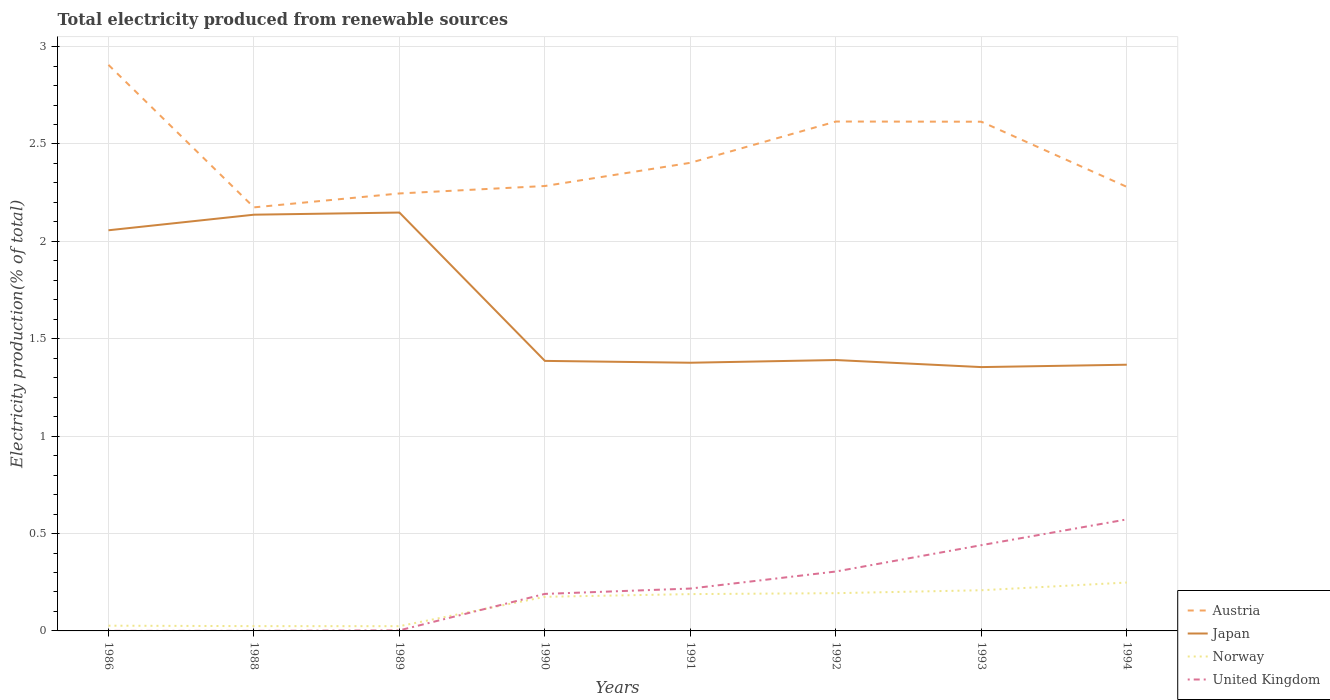Does the line corresponding to Norway intersect with the line corresponding to Japan?
Keep it short and to the point. No. Across all years, what is the maximum total electricity produced in Austria?
Ensure brevity in your answer.  2.17. What is the total total electricity produced in United Kingdom in the graph?
Offer a terse response. -0.22. What is the difference between the highest and the second highest total electricity produced in United Kingdom?
Make the answer very short. 0.57. What is the difference between the highest and the lowest total electricity produced in Austria?
Provide a short and direct response. 3. How many lines are there?
Offer a very short reply. 4. How many years are there in the graph?
Your answer should be compact. 8. What is the difference between two consecutive major ticks on the Y-axis?
Your answer should be very brief. 0.5. Does the graph contain any zero values?
Your answer should be very brief. No. Does the graph contain grids?
Your answer should be very brief. Yes. How are the legend labels stacked?
Your answer should be very brief. Vertical. What is the title of the graph?
Keep it short and to the point. Total electricity produced from renewable sources. What is the label or title of the Y-axis?
Provide a succinct answer. Electricity production(% of total). What is the Electricity production(% of total) of Austria in 1986?
Provide a short and direct response. 2.91. What is the Electricity production(% of total) in Japan in 1986?
Make the answer very short. 2.06. What is the Electricity production(% of total) in Norway in 1986?
Provide a short and direct response. 0.03. What is the Electricity production(% of total) of United Kingdom in 1986?
Ensure brevity in your answer.  0. What is the Electricity production(% of total) in Austria in 1988?
Keep it short and to the point. 2.17. What is the Electricity production(% of total) of Japan in 1988?
Give a very brief answer. 2.14. What is the Electricity production(% of total) of Norway in 1988?
Ensure brevity in your answer.  0.02. What is the Electricity production(% of total) of United Kingdom in 1988?
Offer a terse response. 0. What is the Electricity production(% of total) of Austria in 1989?
Your answer should be very brief. 2.25. What is the Electricity production(% of total) of Japan in 1989?
Your answer should be very brief. 2.15. What is the Electricity production(% of total) of Norway in 1989?
Provide a short and direct response. 0.02. What is the Electricity production(% of total) in United Kingdom in 1989?
Offer a very short reply. 0. What is the Electricity production(% of total) in Austria in 1990?
Your response must be concise. 2.28. What is the Electricity production(% of total) of Japan in 1990?
Offer a terse response. 1.39. What is the Electricity production(% of total) of Norway in 1990?
Your response must be concise. 0.18. What is the Electricity production(% of total) in United Kingdom in 1990?
Your answer should be compact. 0.19. What is the Electricity production(% of total) of Austria in 1991?
Your answer should be very brief. 2.4. What is the Electricity production(% of total) of Japan in 1991?
Your response must be concise. 1.38. What is the Electricity production(% of total) of Norway in 1991?
Your response must be concise. 0.19. What is the Electricity production(% of total) in United Kingdom in 1991?
Offer a terse response. 0.22. What is the Electricity production(% of total) in Austria in 1992?
Provide a short and direct response. 2.62. What is the Electricity production(% of total) in Japan in 1992?
Provide a short and direct response. 1.39. What is the Electricity production(% of total) of Norway in 1992?
Your response must be concise. 0.19. What is the Electricity production(% of total) in United Kingdom in 1992?
Provide a short and direct response. 0.3. What is the Electricity production(% of total) in Austria in 1993?
Offer a terse response. 2.61. What is the Electricity production(% of total) in Japan in 1993?
Ensure brevity in your answer.  1.35. What is the Electricity production(% of total) of Norway in 1993?
Provide a succinct answer. 0.21. What is the Electricity production(% of total) of United Kingdom in 1993?
Offer a very short reply. 0.44. What is the Electricity production(% of total) in Austria in 1994?
Offer a terse response. 2.28. What is the Electricity production(% of total) in Japan in 1994?
Make the answer very short. 1.37. What is the Electricity production(% of total) in Norway in 1994?
Ensure brevity in your answer.  0.25. What is the Electricity production(% of total) of United Kingdom in 1994?
Make the answer very short. 0.57. Across all years, what is the maximum Electricity production(% of total) of Austria?
Provide a succinct answer. 2.91. Across all years, what is the maximum Electricity production(% of total) of Japan?
Provide a short and direct response. 2.15. Across all years, what is the maximum Electricity production(% of total) of Norway?
Offer a very short reply. 0.25. Across all years, what is the maximum Electricity production(% of total) in United Kingdom?
Offer a terse response. 0.57. Across all years, what is the minimum Electricity production(% of total) in Austria?
Provide a short and direct response. 2.17. Across all years, what is the minimum Electricity production(% of total) of Japan?
Your answer should be very brief. 1.35. Across all years, what is the minimum Electricity production(% of total) of Norway?
Your answer should be compact. 0.02. Across all years, what is the minimum Electricity production(% of total) of United Kingdom?
Offer a terse response. 0. What is the total Electricity production(% of total) in Austria in the graph?
Keep it short and to the point. 19.52. What is the total Electricity production(% of total) of Japan in the graph?
Ensure brevity in your answer.  13.22. What is the total Electricity production(% of total) of Norway in the graph?
Keep it short and to the point. 1.09. What is the total Electricity production(% of total) in United Kingdom in the graph?
Give a very brief answer. 1.73. What is the difference between the Electricity production(% of total) of Austria in 1986 and that in 1988?
Ensure brevity in your answer.  0.73. What is the difference between the Electricity production(% of total) in Japan in 1986 and that in 1988?
Your response must be concise. -0.08. What is the difference between the Electricity production(% of total) in Norway in 1986 and that in 1988?
Your answer should be very brief. 0. What is the difference between the Electricity production(% of total) in United Kingdom in 1986 and that in 1988?
Provide a succinct answer. 0. What is the difference between the Electricity production(% of total) of Austria in 1986 and that in 1989?
Give a very brief answer. 0.66. What is the difference between the Electricity production(% of total) in Japan in 1986 and that in 1989?
Your response must be concise. -0.09. What is the difference between the Electricity production(% of total) of Norway in 1986 and that in 1989?
Give a very brief answer. 0. What is the difference between the Electricity production(% of total) in United Kingdom in 1986 and that in 1989?
Your answer should be compact. -0. What is the difference between the Electricity production(% of total) in Austria in 1986 and that in 1990?
Provide a succinct answer. 0.62. What is the difference between the Electricity production(% of total) of Japan in 1986 and that in 1990?
Give a very brief answer. 0.67. What is the difference between the Electricity production(% of total) in Norway in 1986 and that in 1990?
Provide a short and direct response. -0.15. What is the difference between the Electricity production(% of total) in United Kingdom in 1986 and that in 1990?
Offer a very short reply. -0.19. What is the difference between the Electricity production(% of total) in Austria in 1986 and that in 1991?
Your answer should be compact. 0.5. What is the difference between the Electricity production(% of total) in Japan in 1986 and that in 1991?
Ensure brevity in your answer.  0.68. What is the difference between the Electricity production(% of total) in Norway in 1986 and that in 1991?
Provide a succinct answer. -0.16. What is the difference between the Electricity production(% of total) of United Kingdom in 1986 and that in 1991?
Provide a succinct answer. -0.22. What is the difference between the Electricity production(% of total) in Austria in 1986 and that in 1992?
Your answer should be very brief. 0.29. What is the difference between the Electricity production(% of total) of Japan in 1986 and that in 1992?
Make the answer very short. 0.67. What is the difference between the Electricity production(% of total) of Norway in 1986 and that in 1992?
Offer a terse response. -0.17. What is the difference between the Electricity production(% of total) of United Kingdom in 1986 and that in 1992?
Provide a succinct answer. -0.3. What is the difference between the Electricity production(% of total) of Austria in 1986 and that in 1993?
Your response must be concise. 0.29. What is the difference between the Electricity production(% of total) in Japan in 1986 and that in 1993?
Your answer should be compact. 0.7. What is the difference between the Electricity production(% of total) of Norway in 1986 and that in 1993?
Offer a very short reply. -0.18. What is the difference between the Electricity production(% of total) of United Kingdom in 1986 and that in 1993?
Your answer should be compact. -0.44. What is the difference between the Electricity production(% of total) in Austria in 1986 and that in 1994?
Your response must be concise. 0.63. What is the difference between the Electricity production(% of total) in Japan in 1986 and that in 1994?
Offer a terse response. 0.69. What is the difference between the Electricity production(% of total) of Norway in 1986 and that in 1994?
Give a very brief answer. -0.22. What is the difference between the Electricity production(% of total) in United Kingdom in 1986 and that in 1994?
Your response must be concise. -0.57. What is the difference between the Electricity production(% of total) in Austria in 1988 and that in 1989?
Provide a succinct answer. -0.07. What is the difference between the Electricity production(% of total) of Japan in 1988 and that in 1989?
Your answer should be compact. -0.01. What is the difference between the Electricity production(% of total) of Norway in 1988 and that in 1989?
Provide a short and direct response. 0. What is the difference between the Electricity production(% of total) of United Kingdom in 1988 and that in 1989?
Ensure brevity in your answer.  -0. What is the difference between the Electricity production(% of total) in Austria in 1988 and that in 1990?
Your response must be concise. -0.11. What is the difference between the Electricity production(% of total) in Japan in 1988 and that in 1990?
Provide a succinct answer. 0.75. What is the difference between the Electricity production(% of total) in Norway in 1988 and that in 1990?
Give a very brief answer. -0.15. What is the difference between the Electricity production(% of total) in United Kingdom in 1988 and that in 1990?
Make the answer very short. -0.19. What is the difference between the Electricity production(% of total) of Austria in 1988 and that in 1991?
Your answer should be very brief. -0.23. What is the difference between the Electricity production(% of total) in Japan in 1988 and that in 1991?
Your answer should be very brief. 0.76. What is the difference between the Electricity production(% of total) in Norway in 1988 and that in 1991?
Your answer should be very brief. -0.16. What is the difference between the Electricity production(% of total) of United Kingdom in 1988 and that in 1991?
Keep it short and to the point. -0.22. What is the difference between the Electricity production(% of total) of Austria in 1988 and that in 1992?
Provide a short and direct response. -0.44. What is the difference between the Electricity production(% of total) of Japan in 1988 and that in 1992?
Your answer should be very brief. 0.75. What is the difference between the Electricity production(% of total) of Norway in 1988 and that in 1992?
Your answer should be compact. -0.17. What is the difference between the Electricity production(% of total) in United Kingdom in 1988 and that in 1992?
Keep it short and to the point. -0.3. What is the difference between the Electricity production(% of total) of Austria in 1988 and that in 1993?
Keep it short and to the point. -0.44. What is the difference between the Electricity production(% of total) in Japan in 1988 and that in 1993?
Make the answer very short. 0.78. What is the difference between the Electricity production(% of total) in Norway in 1988 and that in 1993?
Give a very brief answer. -0.18. What is the difference between the Electricity production(% of total) of United Kingdom in 1988 and that in 1993?
Offer a very short reply. -0.44. What is the difference between the Electricity production(% of total) in Austria in 1988 and that in 1994?
Ensure brevity in your answer.  -0.11. What is the difference between the Electricity production(% of total) in Japan in 1988 and that in 1994?
Provide a succinct answer. 0.77. What is the difference between the Electricity production(% of total) of Norway in 1988 and that in 1994?
Provide a short and direct response. -0.22. What is the difference between the Electricity production(% of total) in United Kingdom in 1988 and that in 1994?
Your response must be concise. -0.57. What is the difference between the Electricity production(% of total) of Austria in 1989 and that in 1990?
Provide a succinct answer. -0.04. What is the difference between the Electricity production(% of total) of Japan in 1989 and that in 1990?
Give a very brief answer. 0.76. What is the difference between the Electricity production(% of total) of Norway in 1989 and that in 1990?
Offer a very short reply. -0.15. What is the difference between the Electricity production(% of total) in United Kingdom in 1989 and that in 1990?
Make the answer very short. -0.19. What is the difference between the Electricity production(% of total) in Austria in 1989 and that in 1991?
Your response must be concise. -0.16. What is the difference between the Electricity production(% of total) in Japan in 1989 and that in 1991?
Offer a terse response. 0.77. What is the difference between the Electricity production(% of total) in Norway in 1989 and that in 1991?
Ensure brevity in your answer.  -0.16. What is the difference between the Electricity production(% of total) of United Kingdom in 1989 and that in 1991?
Provide a short and direct response. -0.21. What is the difference between the Electricity production(% of total) in Austria in 1989 and that in 1992?
Provide a short and direct response. -0.37. What is the difference between the Electricity production(% of total) in Japan in 1989 and that in 1992?
Keep it short and to the point. 0.76. What is the difference between the Electricity production(% of total) in Norway in 1989 and that in 1992?
Keep it short and to the point. -0.17. What is the difference between the Electricity production(% of total) in United Kingdom in 1989 and that in 1992?
Your answer should be compact. -0.3. What is the difference between the Electricity production(% of total) of Austria in 1989 and that in 1993?
Provide a short and direct response. -0.37. What is the difference between the Electricity production(% of total) in Japan in 1989 and that in 1993?
Provide a short and direct response. 0.79. What is the difference between the Electricity production(% of total) of Norway in 1989 and that in 1993?
Ensure brevity in your answer.  -0.18. What is the difference between the Electricity production(% of total) in United Kingdom in 1989 and that in 1993?
Your response must be concise. -0.44. What is the difference between the Electricity production(% of total) in Austria in 1989 and that in 1994?
Your answer should be compact. -0.03. What is the difference between the Electricity production(% of total) in Japan in 1989 and that in 1994?
Keep it short and to the point. 0.78. What is the difference between the Electricity production(% of total) of Norway in 1989 and that in 1994?
Keep it short and to the point. -0.22. What is the difference between the Electricity production(% of total) in United Kingdom in 1989 and that in 1994?
Keep it short and to the point. -0.57. What is the difference between the Electricity production(% of total) of Austria in 1990 and that in 1991?
Provide a succinct answer. -0.12. What is the difference between the Electricity production(% of total) in Japan in 1990 and that in 1991?
Provide a short and direct response. 0.01. What is the difference between the Electricity production(% of total) in Norway in 1990 and that in 1991?
Provide a short and direct response. -0.01. What is the difference between the Electricity production(% of total) in United Kingdom in 1990 and that in 1991?
Give a very brief answer. -0.03. What is the difference between the Electricity production(% of total) of Austria in 1990 and that in 1992?
Offer a terse response. -0.33. What is the difference between the Electricity production(% of total) of Japan in 1990 and that in 1992?
Your response must be concise. -0. What is the difference between the Electricity production(% of total) in Norway in 1990 and that in 1992?
Offer a very short reply. -0.02. What is the difference between the Electricity production(% of total) of United Kingdom in 1990 and that in 1992?
Make the answer very short. -0.11. What is the difference between the Electricity production(% of total) of Austria in 1990 and that in 1993?
Provide a succinct answer. -0.33. What is the difference between the Electricity production(% of total) of Japan in 1990 and that in 1993?
Your answer should be compact. 0.03. What is the difference between the Electricity production(% of total) in Norway in 1990 and that in 1993?
Your answer should be compact. -0.03. What is the difference between the Electricity production(% of total) of United Kingdom in 1990 and that in 1993?
Give a very brief answer. -0.25. What is the difference between the Electricity production(% of total) in Austria in 1990 and that in 1994?
Provide a succinct answer. 0. What is the difference between the Electricity production(% of total) in Japan in 1990 and that in 1994?
Ensure brevity in your answer.  0.02. What is the difference between the Electricity production(% of total) in Norway in 1990 and that in 1994?
Offer a terse response. -0.07. What is the difference between the Electricity production(% of total) of United Kingdom in 1990 and that in 1994?
Provide a succinct answer. -0.38. What is the difference between the Electricity production(% of total) in Austria in 1991 and that in 1992?
Keep it short and to the point. -0.21. What is the difference between the Electricity production(% of total) of Japan in 1991 and that in 1992?
Make the answer very short. -0.01. What is the difference between the Electricity production(% of total) of Norway in 1991 and that in 1992?
Ensure brevity in your answer.  -0. What is the difference between the Electricity production(% of total) of United Kingdom in 1991 and that in 1992?
Offer a terse response. -0.09. What is the difference between the Electricity production(% of total) of Austria in 1991 and that in 1993?
Provide a short and direct response. -0.21. What is the difference between the Electricity production(% of total) in Japan in 1991 and that in 1993?
Your answer should be very brief. 0.02. What is the difference between the Electricity production(% of total) in Norway in 1991 and that in 1993?
Your answer should be very brief. -0.02. What is the difference between the Electricity production(% of total) in United Kingdom in 1991 and that in 1993?
Your response must be concise. -0.22. What is the difference between the Electricity production(% of total) in Austria in 1991 and that in 1994?
Your answer should be compact. 0.12. What is the difference between the Electricity production(% of total) in Japan in 1991 and that in 1994?
Keep it short and to the point. 0.01. What is the difference between the Electricity production(% of total) in Norway in 1991 and that in 1994?
Your answer should be compact. -0.06. What is the difference between the Electricity production(% of total) of United Kingdom in 1991 and that in 1994?
Give a very brief answer. -0.36. What is the difference between the Electricity production(% of total) in Austria in 1992 and that in 1993?
Your response must be concise. 0. What is the difference between the Electricity production(% of total) of Japan in 1992 and that in 1993?
Ensure brevity in your answer.  0.04. What is the difference between the Electricity production(% of total) of Norway in 1992 and that in 1993?
Your response must be concise. -0.01. What is the difference between the Electricity production(% of total) of United Kingdom in 1992 and that in 1993?
Your response must be concise. -0.14. What is the difference between the Electricity production(% of total) of Austria in 1992 and that in 1994?
Your answer should be compact. 0.34. What is the difference between the Electricity production(% of total) of Japan in 1992 and that in 1994?
Your answer should be very brief. 0.02. What is the difference between the Electricity production(% of total) in Norway in 1992 and that in 1994?
Your answer should be very brief. -0.05. What is the difference between the Electricity production(% of total) in United Kingdom in 1992 and that in 1994?
Give a very brief answer. -0.27. What is the difference between the Electricity production(% of total) of Austria in 1993 and that in 1994?
Offer a terse response. 0.33. What is the difference between the Electricity production(% of total) of Japan in 1993 and that in 1994?
Offer a very short reply. -0.01. What is the difference between the Electricity production(% of total) of Norway in 1993 and that in 1994?
Offer a terse response. -0.04. What is the difference between the Electricity production(% of total) of United Kingdom in 1993 and that in 1994?
Your response must be concise. -0.13. What is the difference between the Electricity production(% of total) of Austria in 1986 and the Electricity production(% of total) of Japan in 1988?
Your response must be concise. 0.77. What is the difference between the Electricity production(% of total) of Austria in 1986 and the Electricity production(% of total) of Norway in 1988?
Give a very brief answer. 2.88. What is the difference between the Electricity production(% of total) in Austria in 1986 and the Electricity production(% of total) in United Kingdom in 1988?
Make the answer very short. 2.91. What is the difference between the Electricity production(% of total) of Japan in 1986 and the Electricity production(% of total) of Norway in 1988?
Offer a very short reply. 2.03. What is the difference between the Electricity production(% of total) of Japan in 1986 and the Electricity production(% of total) of United Kingdom in 1988?
Provide a succinct answer. 2.06. What is the difference between the Electricity production(% of total) in Norway in 1986 and the Electricity production(% of total) in United Kingdom in 1988?
Your response must be concise. 0.03. What is the difference between the Electricity production(% of total) in Austria in 1986 and the Electricity production(% of total) in Japan in 1989?
Give a very brief answer. 0.76. What is the difference between the Electricity production(% of total) in Austria in 1986 and the Electricity production(% of total) in Norway in 1989?
Ensure brevity in your answer.  2.88. What is the difference between the Electricity production(% of total) of Austria in 1986 and the Electricity production(% of total) of United Kingdom in 1989?
Keep it short and to the point. 2.9. What is the difference between the Electricity production(% of total) in Japan in 1986 and the Electricity production(% of total) in Norway in 1989?
Give a very brief answer. 2.03. What is the difference between the Electricity production(% of total) in Japan in 1986 and the Electricity production(% of total) in United Kingdom in 1989?
Your response must be concise. 2.05. What is the difference between the Electricity production(% of total) in Norway in 1986 and the Electricity production(% of total) in United Kingdom in 1989?
Your answer should be very brief. 0.02. What is the difference between the Electricity production(% of total) of Austria in 1986 and the Electricity production(% of total) of Japan in 1990?
Offer a very short reply. 1.52. What is the difference between the Electricity production(% of total) in Austria in 1986 and the Electricity production(% of total) in Norway in 1990?
Your answer should be very brief. 2.73. What is the difference between the Electricity production(% of total) of Austria in 1986 and the Electricity production(% of total) of United Kingdom in 1990?
Offer a terse response. 2.72. What is the difference between the Electricity production(% of total) in Japan in 1986 and the Electricity production(% of total) in Norway in 1990?
Give a very brief answer. 1.88. What is the difference between the Electricity production(% of total) of Japan in 1986 and the Electricity production(% of total) of United Kingdom in 1990?
Ensure brevity in your answer.  1.87. What is the difference between the Electricity production(% of total) in Norway in 1986 and the Electricity production(% of total) in United Kingdom in 1990?
Offer a terse response. -0.16. What is the difference between the Electricity production(% of total) in Austria in 1986 and the Electricity production(% of total) in Japan in 1991?
Ensure brevity in your answer.  1.53. What is the difference between the Electricity production(% of total) of Austria in 1986 and the Electricity production(% of total) of Norway in 1991?
Provide a succinct answer. 2.72. What is the difference between the Electricity production(% of total) in Austria in 1986 and the Electricity production(% of total) in United Kingdom in 1991?
Provide a short and direct response. 2.69. What is the difference between the Electricity production(% of total) in Japan in 1986 and the Electricity production(% of total) in Norway in 1991?
Give a very brief answer. 1.87. What is the difference between the Electricity production(% of total) in Japan in 1986 and the Electricity production(% of total) in United Kingdom in 1991?
Offer a terse response. 1.84. What is the difference between the Electricity production(% of total) in Norway in 1986 and the Electricity production(% of total) in United Kingdom in 1991?
Ensure brevity in your answer.  -0.19. What is the difference between the Electricity production(% of total) in Austria in 1986 and the Electricity production(% of total) in Japan in 1992?
Provide a short and direct response. 1.52. What is the difference between the Electricity production(% of total) of Austria in 1986 and the Electricity production(% of total) of Norway in 1992?
Give a very brief answer. 2.71. What is the difference between the Electricity production(% of total) in Austria in 1986 and the Electricity production(% of total) in United Kingdom in 1992?
Offer a very short reply. 2.6. What is the difference between the Electricity production(% of total) in Japan in 1986 and the Electricity production(% of total) in Norway in 1992?
Keep it short and to the point. 1.86. What is the difference between the Electricity production(% of total) in Japan in 1986 and the Electricity production(% of total) in United Kingdom in 1992?
Keep it short and to the point. 1.75. What is the difference between the Electricity production(% of total) of Norway in 1986 and the Electricity production(% of total) of United Kingdom in 1992?
Your response must be concise. -0.28. What is the difference between the Electricity production(% of total) of Austria in 1986 and the Electricity production(% of total) of Japan in 1993?
Make the answer very short. 1.55. What is the difference between the Electricity production(% of total) in Austria in 1986 and the Electricity production(% of total) in Norway in 1993?
Keep it short and to the point. 2.7. What is the difference between the Electricity production(% of total) of Austria in 1986 and the Electricity production(% of total) of United Kingdom in 1993?
Offer a terse response. 2.47. What is the difference between the Electricity production(% of total) of Japan in 1986 and the Electricity production(% of total) of Norway in 1993?
Keep it short and to the point. 1.85. What is the difference between the Electricity production(% of total) in Japan in 1986 and the Electricity production(% of total) in United Kingdom in 1993?
Offer a very short reply. 1.62. What is the difference between the Electricity production(% of total) of Norway in 1986 and the Electricity production(% of total) of United Kingdom in 1993?
Keep it short and to the point. -0.41. What is the difference between the Electricity production(% of total) of Austria in 1986 and the Electricity production(% of total) of Japan in 1994?
Offer a terse response. 1.54. What is the difference between the Electricity production(% of total) of Austria in 1986 and the Electricity production(% of total) of Norway in 1994?
Your answer should be very brief. 2.66. What is the difference between the Electricity production(% of total) in Austria in 1986 and the Electricity production(% of total) in United Kingdom in 1994?
Your answer should be very brief. 2.33. What is the difference between the Electricity production(% of total) in Japan in 1986 and the Electricity production(% of total) in Norway in 1994?
Provide a short and direct response. 1.81. What is the difference between the Electricity production(% of total) in Japan in 1986 and the Electricity production(% of total) in United Kingdom in 1994?
Keep it short and to the point. 1.48. What is the difference between the Electricity production(% of total) in Norway in 1986 and the Electricity production(% of total) in United Kingdom in 1994?
Your answer should be compact. -0.55. What is the difference between the Electricity production(% of total) in Austria in 1988 and the Electricity production(% of total) in Japan in 1989?
Provide a short and direct response. 0.03. What is the difference between the Electricity production(% of total) in Austria in 1988 and the Electricity production(% of total) in Norway in 1989?
Keep it short and to the point. 2.15. What is the difference between the Electricity production(% of total) in Austria in 1988 and the Electricity production(% of total) in United Kingdom in 1989?
Your response must be concise. 2.17. What is the difference between the Electricity production(% of total) of Japan in 1988 and the Electricity production(% of total) of Norway in 1989?
Offer a terse response. 2.11. What is the difference between the Electricity production(% of total) in Japan in 1988 and the Electricity production(% of total) in United Kingdom in 1989?
Offer a very short reply. 2.13. What is the difference between the Electricity production(% of total) in Norway in 1988 and the Electricity production(% of total) in United Kingdom in 1989?
Provide a short and direct response. 0.02. What is the difference between the Electricity production(% of total) of Austria in 1988 and the Electricity production(% of total) of Japan in 1990?
Provide a succinct answer. 0.79. What is the difference between the Electricity production(% of total) in Austria in 1988 and the Electricity production(% of total) in Norway in 1990?
Offer a very short reply. 2. What is the difference between the Electricity production(% of total) of Austria in 1988 and the Electricity production(% of total) of United Kingdom in 1990?
Provide a succinct answer. 1.98. What is the difference between the Electricity production(% of total) in Japan in 1988 and the Electricity production(% of total) in Norway in 1990?
Provide a short and direct response. 1.96. What is the difference between the Electricity production(% of total) in Japan in 1988 and the Electricity production(% of total) in United Kingdom in 1990?
Make the answer very short. 1.95. What is the difference between the Electricity production(% of total) of Norway in 1988 and the Electricity production(% of total) of United Kingdom in 1990?
Keep it short and to the point. -0.17. What is the difference between the Electricity production(% of total) of Austria in 1988 and the Electricity production(% of total) of Japan in 1991?
Give a very brief answer. 0.8. What is the difference between the Electricity production(% of total) of Austria in 1988 and the Electricity production(% of total) of Norway in 1991?
Make the answer very short. 1.99. What is the difference between the Electricity production(% of total) in Austria in 1988 and the Electricity production(% of total) in United Kingdom in 1991?
Provide a succinct answer. 1.96. What is the difference between the Electricity production(% of total) in Japan in 1988 and the Electricity production(% of total) in Norway in 1991?
Offer a very short reply. 1.95. What is the difference between the Electricity production(% of total) in Japan in 1988 and the Electricity production(% of total) in United Kingdom in 1991?
Offer a terse response. 1.92. What is the difference between the Electricity production(% of total) in Norway in 1988 and the Electricity production(% of total) in United Kingdom in 1991?
Offer a very short reply. -0.19. What is the difference between the Electricity production(% of total) in Austria in 1988 and the Electricity production(% of total) in Japan in 1992?
Make the answer very short. 0.78. What is the difference between the Electricity production(% of total) in Austria in 1988 and the Electricity production(% of total) in Norway in 1992?
Ensure brevity in your answer.  1.98. What is the difference between the Electricity production(% of total) in Austria in 1988 and the Electricity production(% of total) in United Kingdom in 1992?
Offer a very short reply. 1.87. What is the difference between the Electricity production(% of total) in Japan in 1988 and the Electricity production(% of total) in Norway in 1992?
Give a very brief answer. 1.94. What is the difference between the Electricity production(% of total) of Japan in 1988 and the Electricity production(% of total) of United Kingdom in 1992?
Ensure brevity in your answer.  1.83. What is the difference between the Electricity production(% of total) of Norway in 1988 and the Electricity production(% of total) of United Kingdom in 1992?
Provide a short and direct response. -0.28. What is the difference between the Electricity production(% of total) in Austria in 1988 and the Electricity production(% of total) in Japan in 1993?
Provide a succinct answer. 0.82. What is the difference between the Electricity production(% of total) of Austria in 1988 and the Electricity production(% of total) of Norway in 1993?
Make the answer very short. 1.97. What is the difference between the Electricity production(% of total) of Austria in 1988 and the Electricity production(% of total) of United Kingdom in 1993?
Your response must be concise. 1.73. What is the difference between the Electricity production(% of total) of Japan in 1988 and the Electricity production(% of total) of Norway in 1993?
Your answer should be very brief. 1.93. What is the difference between the Electricity production(% of total) in Japan in 1988 and the Electricity production(% of total) in United Kingdom in 1993?
Give a very brief answer. 1.7. What is the difference between the Electricity production(% of total) in Norway in 1988 and the Electricity production(% of total) in United Kingdom in 1993?
Give a very brief answer. -0.42. What is the difference between the Electricity production(% of total) of Austria in 1988 and the Electricity production(% of total) of Japan in 1994?
Offer a very short reply. 0.81. What is the difference between the Electricity production(% of total) in Austria in 1988 and the Electricity production(% of total) in Norway in 1994?
Give a very brief answer. 1.93. What is the difference between the Electricity production(% of total) of Austria in 1988 and the Electricity production(% of total) of United Kingdom in 1994?
Your response must be concise. 1.6. What is the difference between the Electricity production(% of total) in Japan in 1988 and the Electricity production(% of total) in Norway in 1994?
Your answer should be very brief. 1.89. What is the difference between the Electricity production(% of total) in Japan in 1988 and the Electricity production(% of total) in United Kingdom in 1994?
Offer a very short reply. 1.56. What is the difference between the Electricity production(% of total) of Norway in 1988 and the Electricity production(% of total) of United Kingdom in 1994?
Make the answer very short. -0.55. What is the difference between the Electricity production(% of total) of Austria in 1989 and the Electricity production(% of total) of Japan in 1990?
Your response must be concise. 0.86. What is the difference between the Electricity production(% of total) of Austria in 1989 and the Electricity production(% of total) of Norway in 1990?
Keep it short and to the point. 2.07. What is the difference between the Electricity production(% of total) in Austria in 1989 and the Electricity production(% of total) in United Kingdom in 1990?
Offer a very short reply. 2.06. What is the difference between the Electricity production(% of total) in Japan in 1989 and the Electricity production(% of total) in Norway in 1990?
Give a very brief answer. 1.97. What is the difference between the Electricity production(% of total) of Japan in 1989 and the Electricity production(% of total) of United Kingdom in 1990?
Your response must be concise. 1.96. What is the difference between the Electricity production(% of total) in Norway in 1989 and the Electricity production(% of total) in United Kingdom in 1990?
Ensure brevity in your answer.  -0.17. What is the difference between the Electricity production(% of total) in Austria in 1989 and the Electricity production(% of total) in Japan in 1991?
Provide a short and direct response. 0.87. What is the difference between the Electricity production(% of total) of Austria in 1989 and the Electricity production(% of total) of Norway in 1991?
Make the answer very short. 2.06. What is the difference between the Electricity production(% of total) of Austria in 1989 and the Electricity production(% of total) of United Kingdom in 1991?
Provide a short and direct response. 2.03. What is the difference between the Electricity production(% of total) in Japan in 1989 and the Electricity production(% of total) in Norway in 1991?
Ensure brevity in your answer.  1.96. What is the difference between the Electricity production(% of total) in Japan in 1989 and the Electricity production(% of total) in United Kingdom in 1991?
Ensure brevity in your answer.  1.93. What is the difference between the Electricity production(% of total) in Norway in 1989 and the Electricity production(% of total) in United Kingdom in 1991?
Provide a succinct answer. -0.19. What is the difference between the Electricity production(% of total) of Austria in 1989 and the Electricity production(% of total) of Japan in 1992?
Your response must be concise. 0.86. What is the difference between the Electricity production(% of total) of Austria in 1989 and the Electricity production(% of total) of Norway in 1992?
Keep it short and to the point. 2.05. What is the difference between the Electricity production(% of total) in Austria in 1989 and the Electricity production(% of total) in United Kingdom in 1992?
Your answer should be compact. 1.94. What is the difference between the Electricity production(% of total) of Japan in 1989 and the Electricity production(% of total) of Norway in 1992?
Offer a terse response. 1.95. What is the difference between the Electricity production(% of total) in Japan in 1989 and the Electricity production(% of total) in United Kingdom in 1992?
Give a very brief answer. 1.84. What is the difference between the Electricity production(% of total) in Norway in 1989 and the Electricity production(% of total) in United Kingdom in 1992?
Keep it short and to the point. -0.28. What is the difference between the Electricity production(% of total) of Austria in 1989 and the Electricity production(% of total) of Japan in 1993?
Your answer should be very brief. 0.89. What is the difference between the Electricity production(% of total) in Austria in 1989 and the Electricity production(% of total) in Norway in 1993?
Ensure brevity in your answer.  2.04. What is the difference between the Electricity production(% of total) in Austria in 1989 and the Electricity production(% of total) in United Kingdom in 1993?
Offer a terse response. 1.81. What is the difference between the Electricity production(% of total) of Japan in 1989 and the Electricity production(% of total) of Norway in 1993?
Provide a short and direct response. 1.94. What is the difference between the Electricity production(% of total) of Japan in 1989 and the Electricity production(% of total) of United Kingdom in 1993?
Give a very brief answer. 1.71. What is the difference between the Electricity production(% of total) in Norway in 1989 and the Electricity production(% of total) in United Kingdom in 1993?
Ensure brevity in your answer.  -0.42. What is the difference between the Electricity production(% of total) of Austria in 1989 and the Electricity production(% of total) of Japan in 1994?
Provide a succinct answer. 0.88. What is the difference between the Electricity production(% of total) in Austria in 1989 and the Electricity production(% of total) in Norway in 1994?
Your response must be concise. 2. What is the difference between the Electricity production(% of total) in Austria in 1989 and the Electricity production(% of total) in United Kingdom in 1994?
Your answer should be very brief. 1.67. What is the difference between the Electricity production(% of total) in Japan in 1989 and the Electricity production(% of total) in Norway in 1994?
Your answer should be very brief. 1.9. What is the difference between the Electricity production(% of total) in Japan in 1989 and the Electricity production(% of total) in United Kingdom in 1994?
Offer a terse response. 1.58. What is the difference between the Electricity production(% of total) in Norway in 1989 and the Electricity production(% of total) in United Kingdom in 1994?
Make the answer very short. -0.55. What is the difference between the Electricity production(% of total) in Austria in 1990 and the Electricity production(% of total) in Japan in 1991?
Ensure brevity in your answer.  0.91. What is the difference between the Electricity production(% of total) in Austria in 1990 and the Electricity production(% of total) in Norway in 1991?
Keep it short and to the point. 2.1. What is the difference between the Electricity production(% of total) in Austria in 1990 and the Electricity production(% of total) in United Kingdom in 1991?
Your answer should be compact. 2.07. What is the difference between the Electricity production(% of total) of Japan in 1990 and the Electricity production(% of total) of Norway in 1991?
Your answer should be very brief. 1.2. What is the difference between the Electricity production(% of total) of Japan in 1990 and the Electricity production(% of total) of United Kingdom in 1991?
Provide a succinct answer. 1.17. What is the difference between the Electricity production(% of total) of Norway in 1990 and the Electricity production(% of total) of United Kingdom in 1991?
Your response must be concise. -0.04. What is the difference between the Electricity production(% of total) in Austria in 1990 and the Electricity production(% of total) in Japan in 1992?
Ensure brevity in your answer.  0.89. What is the difference between the Electricity production(% of total) of Austria in 1990 and the Electricity production(% of total) of Norway in 1992?
Provide a short and direct response. 2.09. What is the difference between the Electricity production(% of total) in Austria in 1990 and the Electricity production(% of total) in United Kingdom in 1992?
Your answer should be very brief. 1.98. What is the difference between the Electricity production(% of total) of Japan in 1990 and the Electricity production(% of total) of Norway in 1992?
Offer a terse response. 1.19. What is the difference between the Electricity production(% of total) in Japan in 1990 and the Electricity production(% of total) in United Kingdom in 1992?
Provide a succinct answer. 1.08. What is the difference between the Electricity production(% of total) of Norway in 1990 and the Electricity production(% of total) of United Kingdom in 1992?
Offer a terse response. -0.13. What is the difference between the Electricity production(% of total) of Austria in 1990 and the Electricity production(% of total) of Japan in 1993?
Your response must be concise. 0.93. What is the difference between the Electricity production(% of total) of Austria in 1990 and the Electricity production(% of total) of Norway in 1993?
Make the answer very short. 2.08. What is the difference between the Electricity production(% of total) of Austria in 1990 and the Electricity production(% of total) of United Kingdom in 1993?
Ensure brevity in your answer.  1.84. What is the difference between the Electricity production(% of total) in Japan in 1990 and the Electricity production(% of total) in Norway in 1993?
Keep it short and to the point. 1.18. What is the difference between the Electricity production(% of total) of Japan in 1990 and the Electricity production(% of total) of United Kingdom in 1993?
Keep it short and to the point. 0.95. What is the difference between the Electricity production(% of total) in Norway in 1990 and the Electricity production(% of total) in United Kingdom in 1993?
Give a very brief answer. -0.27. What is the difference between the Electricity production(% of total) of Austria in 1990 and the Electricity production(% of total) of Japan in 1994?
Your response must be concise. 0.92. What is the difference between the Electricity production(% of total) in Austria in 1990 and the Electricity production(% of total) in Norway in 1994?
Keep it short and to the point. 2.04. What is the difference between the Electricity production(% of total) of Austria in 1990 and the Electricity production(% of total) of United Kingdom in 1994?
Your answer should be very brief. 1.71. What is the difference between the Electricity production(% of total) of Japan in 1990 and the Electricity production(% of total) of Norway in 1994?
Ensure brevity in your answer.  1.14. What is the difference between the Electricity production(% of total) of Japan in 1990 and the Electricity production(% of total) of United Kingdom in 1994?
Offer a very short reply. 0.81. What is the difference between the Electricity production(% of total) in Norway in 1990 and the Electricity production(% of total) in United Kingdom in 1994?
Your response must be concise. -0.4. What is the difference between the Electricity production(% of total) in Austria in 1991 and the Electricity production(% of total) in Japan in 1992?
Offer a terse response. 1.01. What is the difference between the Electricity production(% of total) in Austria in 1991 and the Electricity production(% of total) in Norway in 1992?
Provide a succinct answer. 2.21. What is the difference between the Electricity production(% of total) in Austria in 1991 and the Electricity production(% of total) in United Kingdom in 1992?
Your answer should be very brief. 2.1. What is the difference between the Electricity production(% of total) in Japan in 1991 and the Electricity production(% of total) in Norway in 1992?
Provide a succinct answer. 1.18. What is the difference between the Electricity production(% of total) in Japan in 1991 and the Electricity production(% of total) in United Kingdom in 1992?
Your answer should be very brief. 1.07. What is the difference between the Electricity production(% of total) of Norway in 1991 and the Electricity production(% of total) of United Kingdom in 1992?
Your answer should be compact. -0.12. What is the difference between the Electricity production(% of total) of Austria in 1991 and the Electricity production(% of total) of Japan in 1993?
Your response must be concise. 1.05. What is the difference between the Electricity production(% of total) in Austria in 1991 and the Electricity production(% of total) in Norway in 1993?
Offer a very short reply. 2.19. What is the difference between the Electricity production(% of total) in Austria in 1991 and the Electricity production(% of total) in United Kingdom in 1993?
Ensure brevity in your answer.  1.96. What is the difference between the Electricity production(% of total) in Japan in 1991 and the Electricity production(% of total) in Norway in 1993?
Offer a very short reply. 1.17. What is the difference between the Electricity production(% of total) in Japan in 1991 and the Electricity production(% of total) in United Kingdom in 1993?
Your answer should be compact. 0.94. What is the difference between the Electricity production(% of total) of Norway in 1991 and the Electricity production(% of total) of United Kingdom in 1993?
Offer a very short reply. -0.25. What is the difference between the Electricity production(% of total) in Austria in 1991 and the Electricity production(% of total) in Japan in 1994?
Your answer should be very brief. 1.04. What is the difference between the Electricity production(% of total) of Austria in 1991 and the Electricity production(% of total) of Norway in 1994?
Make the answer very short. 2.15. What is the difference between the Electricity production(% of total) in Austria in 1991 and the Electricity production(% of total) in United Kingdom in 1994?
Keep it short and to the point. 1.83. What is the difference between the Electricity production(% of total) in Japan in 1991 and the Electricity production(% of total) in Norway in 1994?
Your response must be concise. 1.13. What is the difference between the Electricity production(% of total) in Japan in 1991 and the Electricity production(% of total) in United Kingdom in 1994?
Offer a terse response. 0.8. What is the difference between the Electricity production(% of total) in Norway in 1991 and the Electricity production(% of total) in United Kingdom in 1994?
Offer a terse response. -0.38. What is the difference between the Electricity production(% of total) in Austria in 1992 and the Electricity production(% of total) in Japan in 1993?
Ensure brevity in your answer.  1.26. What is the difference between the Electricity production(% of total) of Austria in 1992 and the Electricity production(% of total) of Norway in 1993?
Keep it short and to the point. 2.41. What is the difference between the Electricity production(% of total) of Austria in 1992 and the Electricity production(% of total) of United Kingdom in 1993?
Your answer should be compact. 2.17. What is the difference between the Electricity production(% of total) in Japan in 1992 and the Electricity production(% of total) in Norway in 1993?
Your answer should be very brief. 1.18. What is the difference between the Electricity production(% of total) in Japan in 1992 and the Electricity production(% of total) in United Kingdom in 1993?
Ensure brevity in your answer.  0.95. What is the difference between the Electricity production(% of total) of Norway in 1992 and the Electricity production(% of total) of United Kingdom in 1993?
Provide a succinct answer. -0.25. What is the difference between the Electricity production(% of total) of Austria in 1992 and the Electricity production(% of total) of Japan in 1994?
Offer a very short reply. 1.25. What is the difference between the Electricity production(% of total) in Austria in 1992 and the Electricity production(% of total) in Norway in 1994?
Offer a terse response. 2.37. What is the difference between the Electricity production(% of total) in Austria in 1992 and the Electricity production(% of total) in United Kingdom in 1994?
Provide a succinct answer. 2.04. What is the difference between the Electricity production(% of total) of Japan in 1992 and the Electricity production(% of total) of Norway in 1994?
Your answer should be compact. 1.14. What is the difference between the Electricity production(% of total) in Japan in 1992 and the Electricity production(% of total) in United Kingdom in 1994?
Offer a very short reply. 0.82. What is the difference between the Electricity production(% of total) of Norway in 1992 and the Electricity production(% of total) of United Kingdom in 1994?
Give a very brief answer. -0.38. What is the difference between the Electricity production(% of total) in Austria in 1993 and the Electricity production(% of total) in Japan in 1994?
Offer a very short reply. 1.25. What is the difference between the Electricity production(% of total) in Austria in 1993 and the Electricity production(% of total) in Norway in 1994?
Your response must be concise. 2.37. What is the difference between the Electricity production(% of total) in Austria in 1993 and the Electricity production(% of total) in United Kingdom in 1994?
Offer a terse response. 2.04. What is the difference between the Electricity production(% of total) of Japan in 1993 and the Electricity production(% of total) of Norway in 1994?
Give a very brief answer. 1.11. What is the difference between the Electricity production(% of total) in Japan in 1993 and the Electricity production(% of total) in United Kingdom in 1994?
Make the answer very short. 0.78. What is the difference between the Electricity production(% of total) of Norway in 1993 and the Electricity production(% of total) of United Kingdom in 1994?
Provide a short and direct response. -0.36. What is the average Electricity production(% of total) in Austria per year?
Give a very brief answer. 2.44. What is the average Electricity production(% of total) of Japan per year?
Your answer should be compact. 1.65. What is the average Electricity production(% of total) of Norway per year?
Ensure brevity in your answer.  0.14. What is the average Electricity production(% of total) in United Kingdom per year?
Ensure brevity in your answer.  0.22. In the year 1986, what is the difference between the Electricity production(% of total) of Austria and Electricity production(% of total) of Japan?
Your answer should be very brief. 0.85. In the year 1986, what is the difference between the Electricity production(% of total) in Austria and Electricity production(% of total) in Norway?
Keep it short and to the point. 2.88. In the year 1986, what is the difference between the Electricity production(% of total) in Austria and Electricity production(% of total) in United Kingdom?
Offer a terse response. 2.91. In the year 1986, what is the difference between the Electricity production(% of total) of Japan and Electricity production(% of total) of Norway?
Offer a terse response. 2.03. In the year 1986, what is the difference between the Electricity production(% of total) in Japan and Electricity production(% of total) in United Kingdom?
Ensure brevity in your answer.  2.06. In the year 1986, what is the difference between the Electricity production(% of total) in Norway and Electricity production(% of total) in United Kingdom?
Provide a short and direct response. 0.03. In the year 1988, what is the difference between the Electricity production(% of total) in Austria and Electricity production(% of total) in Japan?
Provide a succinct answer. 0.04. In the year 1988, what is the difference between the Electricity production(% of total) of Austria and Electricity production(% of total) of Norway?
Give a very brief answer. 2.15. In the year 1988, what is the difference between the Electricity production(% of total) in Austria and Electricity production(% of total) in United Kingdom?
Offer a very short reply. 2.17. In the year 1988, what is the difference between the Electricity production(% of total) of Japan and Electricity production(% of total) of Norway?
Provide a succinct answer. 2.11. In the year 1988, what is the difference between the Electricity production(% of total) of Japan and Electricity production(% of total) of United Kingdom?
Provide a short and direct response. 2.14. In the year 1988, what is the difference between the Electricity production(% of total) in Norway and Electricity production(% of total) in United Kingdom?
Offer a very short reply. 0.02. In the year 1989, what is the difference between the Electricity production(% of total) in Austria and Electricity production(% of total) in Japan?
Offer a terse response. 0.1. In the year 1989, what is the difference between the Electricity production(% of total) in Austria and Electricity production(% of total) in Norway?
Provide a succinct answer. 2.22. In the year 1989, what is the difference between the Electricity production(% of total) of Austria and Electricity production(% of total) of United Kingdom?
Your answer should be compact. 2.24. In the year 1989, what is the difference between the Electricity production(% of total) in Japan and Electricity production(% of total) in Norway?
Your answer should be very brief. 2.12. In the year 1989, what is the difference between the Electricity production(% of total) in Japan and Electricity production(% of total) in United Kingdom?
Offer a very short reply. 2.15. In the year 1989, what is the difference between the Electricity production(% of total) of Norway and Electricity production(% of total) of United Kingdom?
Give a very brief answer. 0.02. In the year 1990, what is the difference between the Electricity production(% of total) of Austria and Electricity production(% of total) of Japan?
Offer a very short reply. 0.9. In the year 1990, what is the difference between the Electricity production(% of total) in Austria and Electricity production(% of total) in Norway?
Provide a short and direct response. 2.11. In the year 1990, what is the difference between the Electricity production(% of total) of Austria and Electricity production(% of total) of United Kingdom?
Ensure brevity in your answer.  2.09. In the year 1990, what is the difference between the Electricity production(% of total) in Japan and Electricity production(% of total) in Norway?
Provide a succinct answer. 1.21. In the year 1990, what is the difference between the Electricity production(% of total) in Japan and Electricity production(% of total) in United Kingdom?
Make the answer very short. 1.2. In the year 1990, what is the difference between the Electricity production(% of total) in Norway and Electricity production(% of total) in United Kingdom?
Give a very brief answer. -0.01. In the year 1991, what is the difference between the Electricity production(% of total) in Austria and Electricity production(% of total) in Japan?
Ensure brevity in your answer.  1.03. In the year 1991, what is the difference between the Electricity production(% of total) of Austria and Electricity production(% of total) of Norway?
Offer a very short reply. 2.21. In the year 1991, what is the difference between the Electricity production(% of total) in Austria and Electricity production(% of total) in United Kingdom?
Give a very brief answer. 2.19. In the year 1991, what is the difference between the Electricity production(% of total) in Japan and Electricity production(% of total) in Norway?
Offer a very short reply. 1.19. In the year 1991, what is the difference between the Electricity production(% of total) in Japan and Electricity production(% of total) in United Kingdom?
Make the answer very short. 1.16. In the year 1991, what is the difference between the Electricity production(% of total) of Norway and Electricity production(% of total) of United Kingdom?
Provide a succinct answer. -0.03. In the year 1992, what is the difference between the Electricity production(% of total) of Austria and Electricity production(% of total) of Japan?
Your answer should be very brief. 1.22. In the year 1992, what is the difference between the Electricity production(% of total) of Austria and Electricity production(% of total) of Norway?
Your answer should be compact. 2.42. In the year 1992, what is the difference between the Electricity production(% of total) in Austria and Electricity production(% of total) in United Kingdom?
Keep it short and to the point. 2.31. In the year 1992, what is the difference between the Electricity production(% of total) of Japan and Electricity production(% of total) of Norway?
Offer a very short reply. 1.2. In the year 1992, what is the difference between the Electricity production(% of total) in Japan and Electricity production(% of total) in United Kingdom?
Your response must be concise. 1.09. In the year 1992, what is the difference between the Electricity production(% of total) of Norway and Electricity production(% of total) of United Kingdom?
Offer a very short reply. -0.11. In the year 1993, what is the difference between the Electricity production(% of total) in Austria and Electricity production(% of total) in Japan?
Make the answer very short. 1.26. In the year 1993, what is the difference between the Electricity production(% of total) of Austria and Electricity production(% of total) of Norway?
Provide a short and direct response. 2.41. In the year 1993, what is the difference between the Electricity production(% of total) in Austria and Electricity production(% of total) in United Kingdom?
Make the answer very short. 2.17. In the year 1993, what is the difference between the Electricity production(% of total) in Japan and Electricity production(% of total) in Norway?
Keep it short and to the point. 1.15. In the year 1993, what is the difference between the Electricity production(% of total) of Japan and Electricity production(% of total) of United Kingdom?
Your response must be concise. 0.91. In the year 1993, what is the difference between the Electricity production(% of total) in Norway and Electricity production(% of total) in United Kingdom?
Provide a short and direct response. -0.23. In the year 1994, what is the difference between the Electricity production(% of total) in Austria and Electricity production(% of total) in Norway?
Keep it short and to the point. 2.03. In the year 1994, what is the difference between the Electricity production(% of total) in Austria and Electricity production(% of total) in United Kingdom?
Keep it short and to the point. 1.71. In the year 1994, what is the difference between the Electricity production(% of total) in Japan and Electricity production(% of total) in Norway?
Give a very brief answer. 1.12. In the year 1994, what is the difference between the Electricity production(% of total) in Japan and Electricity production(% of total) in United Kingdom?
Ensure brevity in your answer.  0.79. In the year 1994, what is the difference between the Electricity production(% of total) of Norway and Electricity production(% of total) of United Kingdom?
Keep it short and to the point. -0.32. What is the ratio of the Electricity production(% of total) in Austria in 1986 to that in 1988?
Ensure brevity in your answer.  1.34. What is the ratio of the Electricity production(% of total) in Japan in 1986 to that in 1988?
Your answer should be very brief. 0.96. What is the ratio of the Electricity production(% of total) in Norway in 1986 to that in 1988?
Give a very brief answer. 1.09. What is the ratio of the Electricity production(% of total) in United Kingdom in 1986 to that in 1988?
Ensure brevity in your answer.  1.02. What is the ratio of the Electricity production(% of total) of Austria in 1986 to that in 1989?
Make the answer very short. 1.29. What is the ratio of the Electricity production(% of total) of Japan in 1986 to that in 1989?
Keep it short and to the point. 0.96. What is the ratio of the Electricity production(% of total) in Norway in 1986 to that in 1989?
Keep it short and to the point. 1.1. What is the ratio of the Electricity production(% of total) of United Kingdom in 1986 to that in 1989?
Your response must be concise. 0.12. What is the ratio of the Electricity production(% of total) in Austria in 1986 to that in 1990?
Keep it short and to the point. 1.27. What is the ratio of the Electricity production(% of total) in Japan in 1986 to that in 1990?
Your answer should be compact. 1.48. What is the ratio of the Electricity production(% of total) of Norway in 1986 to that in 1990?
Offer a terse response. 0.15. What is the ratio of the Electricity production(% of total) of United Kingdom in 1986 to that in 1990?
Your answer should be compact. 0. What is the ratio of the Electricity production(% of total) of Austria in 1986 to that in 1991?
Provide a short and direct response. 1.21. What is the ratio of the Electricity production(% of total) in Japan in 1986 to that in 1991?
Provide a short and direct response. 1.49. What is the ratio of the Electricity production(% of total) of Norway in 1986 to that in 1991?
Provide a short and direct response. 0.14. What is the ratio of the Electricity production(% of total) of United Kingdom in 1986 to that in 1991?
Ensure brevity in your answer.  0. What is the ratio of the Electricity production(% of total) in Austria in 1986 to that in 1992?
Ensure brevity in your answer.  1.11. What is the ratio of the Electricity production(% of total) in Japan in 1986 to that in 1992?
Offer a very short reply. 1.48. What is the ratio of the Electricity production(% of total) in Norway in 1986 to that in 1992?
Offer a terse response. 0.14. What is the ratio of the Electricity production(% of total) in United Kingdom in 1986 to that in 1992?
Make the answer very short. 0. What is the ratio of the Electricity production(% of total) of Austria in 1986 to that in 1993?
Your answer should be compact. 1.11. What is the ratio of the Electricity production(% of total) of Japan in 1986 to that in 1993?
Make the answer very short. 1.52. What is the ratio of the Electricity production(% of total) in Norway in 1986 to that in 1993?
Your answer should be very brief. 0.13. What is the ratio of the Electricity production(% of total) in United Kingdom in 1986 to that in 1993?
Your answer should be very brief. 0. What is the ratio of the Electricity production(% of total) in Austria in 1986 to that in 1994?
Your answer should be very brief. 1.27. What is the ratio of the Electricity production(% of total) in Japan in 1986 to that in 1994?
Your answer should be very brief. 1.5. What is the ratio of the Electricity production(% of total) of Norway in 1986 to that in 1994?
Your answer should be very brief. 0.11. What is the ratio of the Electricity production(% of total) of United Kingdom in 1986 to that in 1994?
Ensure brevity in your answer.  0. What is the ratio of the Electricity production(% of total) of Austria in 1988 to that in 1989?
Keep it short and to the point. 0.97. What is the ratio of the Electricity production(% of total) of Norway in 1988 to that in 1989?
Ensure brevity in your answer.  1.01. What is the ratio of the Electricity production(% of total) of United Kingdom in 1988 to that in 1989?
Give a very brief answer. 0.11. What is the ratio of the Electricity production(% of total) in Japan in 1988 to that in 1990?
Your answer should be compact. 1.54. What is the ratio of the Electricity production(% of total) in Norway in 1988 to that in 1990?
Your response must be concise. 0.14. What is the ratio of the Electricity production(% of total) in United Kingdom in 1988 to that in 1990?
Provide a short and direct response. 0. What is the ratio of the Electricity production(% of total) in Austria in 1988 to that in 1991?
Your answer should be compact. 0.9. What is the ratio of the Electricity production(% of total) of Japan in 1988 to that in 1991?
Make the answer very short. 1.55. What is the ratio of the Electricity production(% of total) of Norway in 1988 to that in 1991?
Make the answer very short. 0.13. What is the ratio of the Electricity production(% of total) of United Kingdom in 1988 to that in 1991?
Provide a succinct answer. 0. What is the ratio of the Electricity production(% of total) in Austria in 1988 to that in 1992?
Provide a short and direct response. 0.83. What is the ratio of the Electricity production(% of total) of Japan in 1988 to that in 1992?
Your response must be concise. 1.54. What is the ratio of the Electricity production(% of total) in Norway in 1988 to that in 1992?
Offer a terse response. 0.13. What is the ratio of the Electricity production(% of total) of United Kingdom in 1988 to that in 1992?
Offer a very short reply. 0. What is the ratio of the Electricity production(% of total) in Austria in 1988 to that in 1993?
Provide a short and direct response. 0.83. What is the ratio of the Electricity production(% of total) of Japan in 1988 to that in 1993?
Offer a very short reply. 1.58. What is the ratio of the Electricity production(% of total) of Norway in 1988 to that in 1993?
Offer a very short reply. 0.12. What is the ratio of the Electricity production(% of total) of United Kingdom in 1988 to that in 1993?
Your response must be concise. 0. What is the ratio of the Electricity production(% of total) in Austria in 1988 to that in 1994?
Give a very brief answer. 0.95. What is the ratio of the Electricity production(% of total) in Japan in 1988 to that in 1994?
Offer a very short reply. 1.56. What is the ratio of the Electricity production(% of total) in Norway in 1988 to that in 1994?
Provide a succinct answer. 0.1. What is the ratio of the Electricity production(% of total) in United Kingdom in 1988 to that in 1994?
Offer a terse response. 0. What is the ratio of the Electricity production(% of total) of Austria in 1989 to that in 1990?
Your response must be concise. 0.98. What is the ratio of the Electricity production(% of total) in Japan in 1989 to that in 1990?
Keep it short and to the point. 1.55. What is the ratio of the Electricity production(% of total) of Norway in 1989 to that in 1990?
Your answer should be compact. 0.14. What is the ratio of the Electricity production(% of total) in United Kingdom in 1989 to that in 1990?
Provide a succinct answer. 0.02. What is the ratio of the Electricity production(% of total) of Austria in 1989 to that in 1991?
Your response must be concise. 0.93. What is the ratio of the Electricity production(% of total) of Japan in 1989 to that in 1991?
Offer a terse response. 1.56. What is the ratio of the Electricity production(% of total) in Norway in 1989 to that in 1991?
Provide a short and direct response. 0.13. What is the ratio of the Electricity production(% of total) of United Kingdom in 1989 to that in 1991?
Your answer should be very brief. 0.01. What is the ratio of the Electricity production(% of total) of Austria in 1989 to that in 1992?
Offer a very short reply. 0.86. What is the ratio of the Electricity production(% of total) in Japan in 1989 to that in 1992?
Offer a terse response. 1.54. What is the ratio of the Electricity production(% of total) of Norway in 1989 to that in 1992?
Your response must be concise. 0.13. What is the ratio of the Electricity production(% of total) in United Kingdom in 1989 to that in 1992?
Keep it short and to the point. 0.01. What is the ratio of the Electricity production(% of total) of Austria in 1989 to that in 1993?
Provide a succinct answer. 0.86. What is the ratio of the Electricity production(% of total) of Japan in 1989 to that in 1993?
Your answer should be very brief. 1.59. What is the ratio of the Electricity production(% of total) of Norway in 1989 to that in 1993?
Provide a succinct answer. 0.12. What is the ratio of the Electricity production(% of total) in United Kingdom in 1989 to that in 1993?
Your answer should be very brief. 0.01. What is the ratio of the Electricity production(% of total) of Austria in 1989 to that in 1994?
Ensure brevity in your answer.  0.99. What is the ratio of the Electricity production(% of total) of Japan in 1989 to that in 1994?
Give a very brief answer. 1.57. What is the ratio of the Electricity production(% of total) of Norway in 1989 to that in 1994?
Make the answer very short. 0.1. What is the ratio of the Electricity production(% of total) of United Kingdom in 1989 to that in 1994?
Your response must be concise. 0.01. What is the ratio of the Electricity production(% of total) in Austria in 1990 to that in 1991?
Provide a succinct answer. 0.95. What is the ratio of the Electricity production(% of total) in Norway in 1990 to that in 1991?
Provide a succinct answer. 0.93. What is the ratio of the Electricity production(% of total) of United Kingdom in 1990 to that in 1991?
Your answer should be very brief. 0.87. What is the ratio of the Electricity production(% of total) in Austria in 1990 to that in 1992?
Offer a terse response. 0.87. What is the ratio of the Electricity production(% of total) in Japan in 1990 to that in 1992?
Provide a short and direct response. 1. What is the ratio of the Electricity production(% of total) of Norway in 1990 to that in 1992?
Offer a very short reply. 0.9. What is the ratio of the Electricity production(% of total) in United Kingdom in 1990 to that in 1992?
Offer a terse response. 0.62. What is the ratio of the Electricity production(% of total) in Austria in 1990 to that in 1993?
Provide a succinct answer. 0.87. What is the ratio of the Electricity production(% of total) in Japan in 1990 to that in 1993?
Give a very brief answer. 1.02. What is the ratio of the Electricity production(% of total) of Norway in 1990 to that in 1993?
Give a very brief answer. 0.84. What is the ratio of the Electricity production(% of total) of United Kingdom in 1990 to that in 1993?
Ensure brevity in your answer.  0.43. What is the ratio of the Electricity production(% of total) in Japan in 1990 to that in 1994?
Offer a terse response. 1.01. What is the ratio of the Electricity production(% of total) of Norway in 1990 to that in 1994?
Your answer should be compact. 0.71. What is the ratio of the Electricity production(% of total) in United Kingdom in 1990 to that in 1994?
Make the answer very short. 0.33. What is the ratio of the Electricity production(% of total) of Austria in 1991 to that in 1992?
Offer a terse response. 0.92. What is the ratio of the Electricity production(% of total) in Norway in 1991 to that in 1992?
Ensure brevity in your answer.  0.98. What is the ratio of the Electricity production(% of total) of United Kingdom in 1991 to that in 1992?
Your answer should be very brief. 0.71. What is the ratio of the Electricity production(% of total) of Austria in 1991 to that in 1993?
Provide a short and direct response. 0.92. What is the ratio of the Electricity production(% of total) of Japan in 1991 to that in 1993?
Give a very brief answer. 1.02. What is the ratio of the Electricity production(% of total) of Norway in 1991 to that in 1993?
Your response must be concise. 0.91. What is the ratio of the Electricity production(% of total) in United Kingdom in 1991 to that in 1993?
Give a very brief answer. 0.49. What is the ratio of the Electricity production(% of total) of Austria in 1991 to that in 1994?
Provide a succinct answer. 1.05. What is the ratio of the Electricity production(% of total) of Japan in 1991 to that in 1994?
Ensure brevity in your answer.  1.01. What is the ratio of the Electricity production(% of total) of Norway in 1991 to that in 1994?
Offer a very short reply. 0.76. What is the ratio of the Electricity production(% of total) of United Kingdom in 1991 to that in 1994?
Make the answer very short. 0.38. What is the ratio of the Electricity production(% of total) in Austria in 1992 to that in 1993?
Keep it short and to the point. 1. What is the ratio of the Electricity production(% of total) of Japan in 1992 to that in 1993?
Keep it short and to the point. 1.03. What is the ratio of the Electricity production(% of total) of Norway in 1992 to that in 1993?
Ensure brevity in your answer.  0.93. What is the ratio of the Electricity production(% of total) in United Kingdom in 1992 to that in 1993?
Make the answer very short. 0.69. What is the ratio of the Electricity production(% of total) of Austria in 1992 to that in 1994?
Provide a short and direct response. 1.15. What is the ratio of the Electricity production(% of total) of Japan in 1992 to that in 1994?
Ensure brevity in your answer.  1.02. What is the ratio of the Electricity production(% of total) of Norway in 1992 to that in 1994?
Offer a very short reply. 0.78. What is the ratio of the Electricity production(% of total) of United Kingdom in 1992 to that in 1994?
Provide a short and direct response. 0.53. What is the ratio of the Electricity production(% of total) in Austria in 1993 to that in 1994?
Offer a very short reply. 1.15. What is the ratio of the Electricity production(% of total) in Norway in 1993 to that in 1994?
Offer a very short reply. 0.84. What is the ratio of the Electricity production(% of total) in United Kingdom in 1993 to that in 1994?
Offer a very short reply. 0.77. What is the difference between the highest and the second highest Electricity production(% of total) of Austria?
Provide a short and direct response. 0.29. What is the difference between the highest and the second highest Electricity production(% of total) in Japan?
Keep it short and to the point. 0.01. What is the difference between the highest and the second highest Electricity production(% of total) of Norway?
Your response must be concise. 0.04. What is the difference between the highest and the second highest Electricity production(% of total) in United Kingdom?
Provide a succinct answer. 0.13. What is the difference between the highest and the lowest Electricity production(% of total) in Austria?
Keep it short and to the point. 0.73. What is the difference between the highest and the lowest Electricity production(% of total) of Japan?
Your answer should be very brief. 0.79. What is the difference between the highest and the lowest Electricity production(% of total) of Norway?
Offer a very short reply. 0.22. What is the difference between the highest and the lowest Electricity production(% of total) in United Kingdom?
Give a very brief answer. 0.57. 